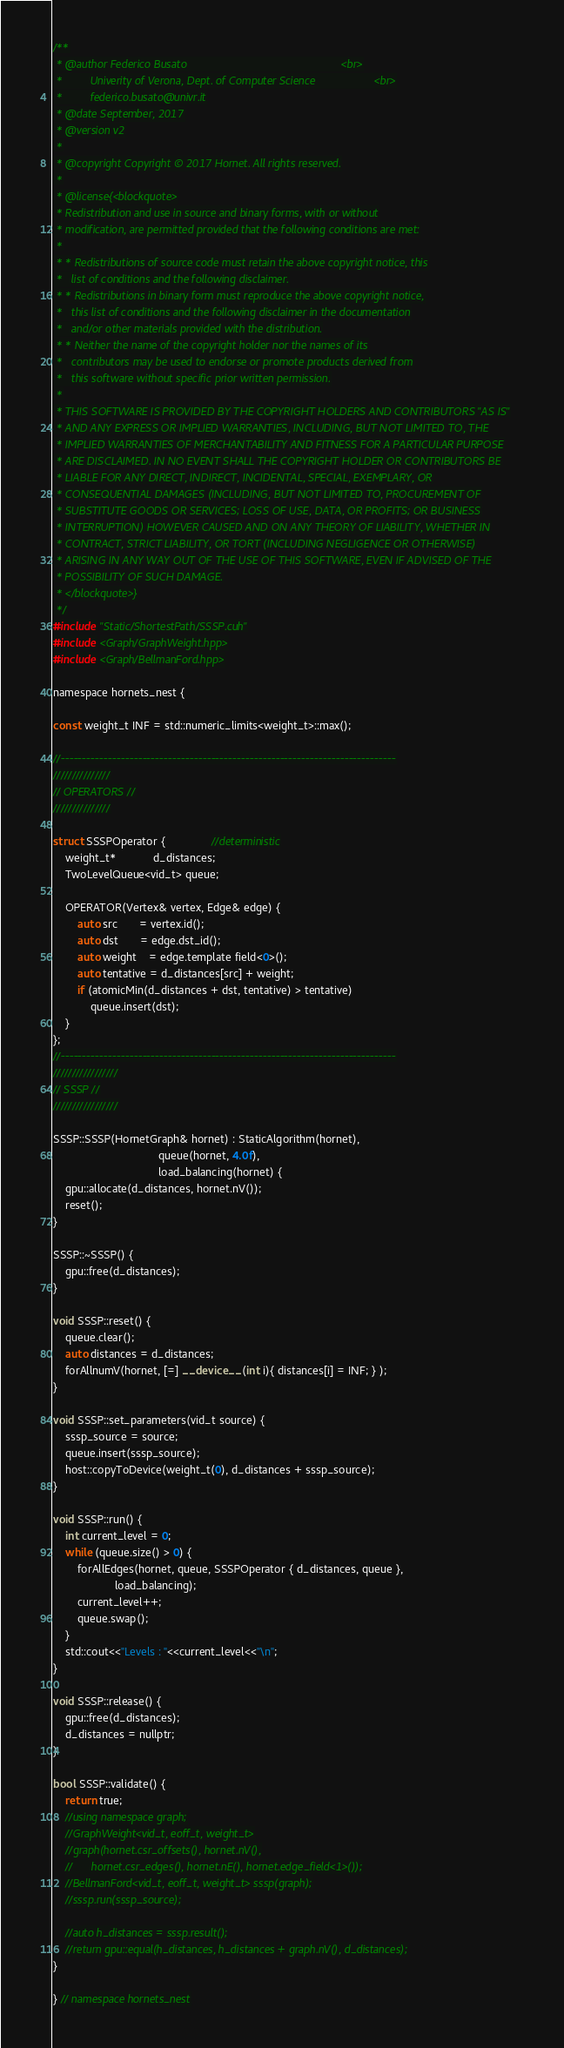<code> <loc_0><loc_0><loc_500><loc_500><_Cuda_>/**
 * @author Federico Busato                                                  <br>
 *         Univerity of Verona, Dept. of Computer Science                   <br>
 *         federico.busato@univr.it
 * @date September, 2017
 * @version v2
 *
 * @copyright Copyright © 2017 Hornet. All rights reserved.
 *
 * @license{<blockquote>
 * Redistribution and use in source and binary forms, with or without
 * modification, are permitted provided that the following conditions are met:
 *
 * * Redistributions of source code must retain the above copyright notice, this
 *   list of conditions and the following disclaimer.
 * * Redistributions in binary form must reproduce the above copyright notice,
 *   this list of conditions and the following disclaimer in the documentation
 *   and/or other materials provided with the distribution.
 * * Neither the name of the copyright holder nor the names of its
 *   contributors may be used to endorse or promote products derived from
 *   this software without specific prior written permission.
 *
 * THIS SOFTWARE IS PROVIDED BY THE COPYRIGHT HOLDERS AND CONTRIBUTORS "AS IS"
 * AND ANY EXPRESS OR IMPLIED WARRANTIES, INCLUDING, BUT NOT LIMITED TO, THE
 * IMPLIED WARRANTIES OF MERCHANTABILITY AND FITNESS FOR A PARTICULAR PURPOSE
 * ARE DISCLAIMED. IN NO EVENT SHALL THE COPYRIGHT HOLDER OR CONTRIBUTORS BE
 * LIABLE FOR ANY DIRECT, INDIRECT, INCIDENTAL, SPECIAL, EXEMPLARY, OR
 * CONSEQUENTIAL DAMAGES (INCLUDING, BUT NOT LIMITED TO, PROCUREMENT OF
 * SUBSTITUTE GOODS OR SERVICES; LOSS OF USE, DATA, OR PROFITS; OR BUSINESS
 * INTERRUPTION) HOWEVER CAUSED AND ON ANY THEORY OF LIABILITY, WHETHER IN
 * CONTRACT, STRICT LIABILITY, OR TORT (INCLUDING NEGLIGENCE OR OTHERWISE)
 * ARISING IN ANY WAY OUT OF THE USE OF THIS SOFTWARE, EVEN IF ADVISED OF THE
 * POSSIBILITY OF SUCH DAMAGE.
 * </blockquote>}
 */
#include "Static/ShortestPath/SSSP.cuh"
#include <Graph/GraphWeight.hpp>
#include <Graph/BellmanFord.hpp>

namespace hornets_nest {

const weight_t INF = std::numeric_limits<weight_t>::max();

//------------------------------------------------------------------------------
///////////////
// OPERATORS //
///////////////

struct SSSPOperator {               //deterministic
    weight_t*            d_distances;
    TwoLevelQueue<vid_t> queue;

    OPERATOR(Vertex& vertex, Edge& edge) {
        auto src       = vertex.id();
        auto dst       = edge.dst_id();
        auto weight    = edge.template field<0>();
        auto tentative = d_distances[src] + weight;
        if (atomicMin(d_distances + dst, tentative) > tentative)
            queue.insert(dst);
    }
};
//------------------------------------------------------------------------------
/////////////////
// SSSP //
/////////////////

SSSP::SSSP(HornetGraph& hornet) : StaticAlgorithm(hornet),
                                  queue(hornet, 4.0f),
                                  load_balancing(hornet) {
    gpu::allocate(d_distances, hornet.nV());
    reset();
}

SSSP::~SSSP() {
    gpu::free(d_distances);
}

void SSSP::reset() {
    queue.clear();
    auto distances = d_distances;
    forAllnumV(hornet, [=] __device__ (int i){ distances[i] = INF; } );
}

void SSSP::set_parameters(vid_t source) {
    sssp_source = source;
    queue.insert(sssp_source);
    host::copyToDevice(weight_t(0), d_distances + sssp_source);
}

void SSSP::run() {
    int current_level = 0;
    while (queue.size() > 0) {
        forAllEdges(hornet, queue, SSSPOperator { d_distances, queue },
                    load_balancing);
        current_level++;
        queue.swap();
    }
    std::cout<<"Levels : "<<current_level<<"\n";
}

void SSSP::release() {
    gpu::free(d_distances);
    d_distances = nullptr;
}

bool SSSP::validate() {
    return true;
    //using namespace graph;
    //GraphWeight<vid_t, eoff_t, weight_t>
    //graph(hornet.csr_offsets(), hornet.nV(),
    //      hornet.csr_edges(), hornet.nE(), hornet.edge_field<1>());
    //BellmanFord<vid_t, eoff_t, weight_t> sssp(graph);
    //sssp.run(sssp_source);

    //auto h_distances = sssp.result();
    //return gpu::equal(h_distances, h_distances + graph.nV(), d_distances);
}

} // namespace hornets_nest
</code> 